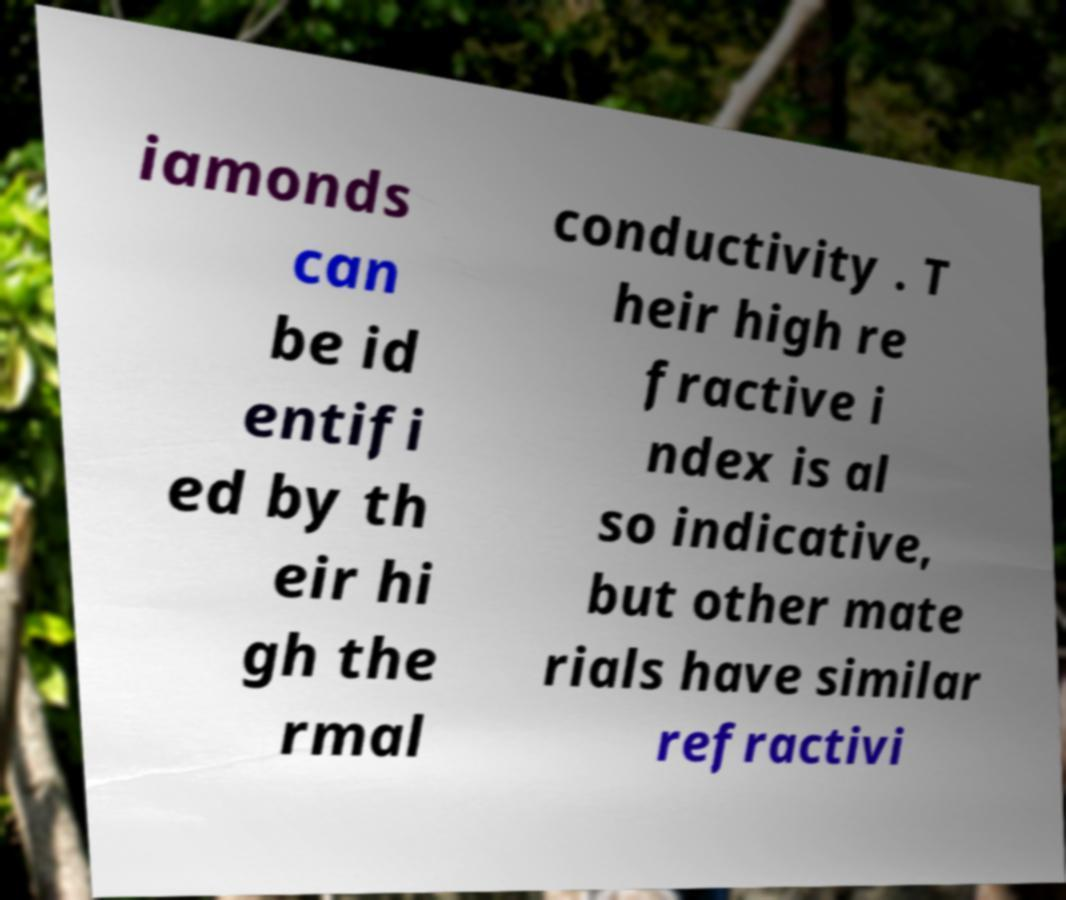I need the written content from this picture converted into text. Can you do that? iamonds can be id entifi ed by th eir hi gh the rmal conductivity . T heir high re fractive i ndex is al so indicative, but other mate rials have similar refractivi 